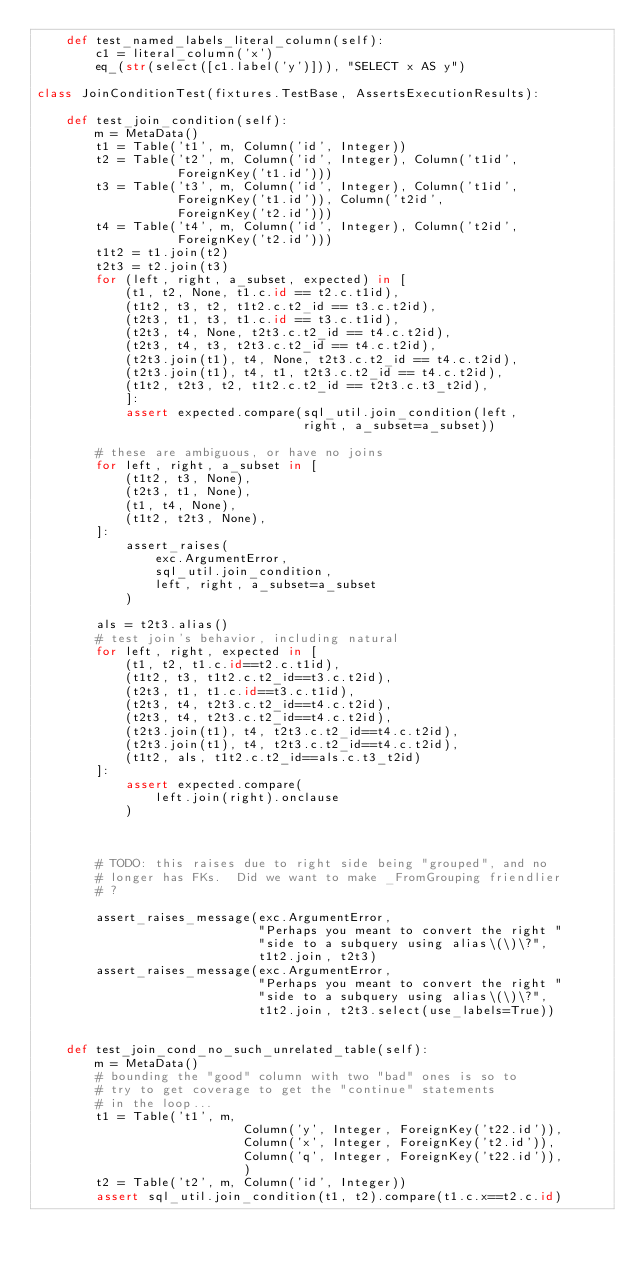Convert code to text. <code><loc_0><loc_0><loc_500><loc_500><_Python_>    def test_named_labels_literal_column(self):
        c1 = literal_column('x')
        eq_(str(select([c1.label('y')])), "SELECT x AS y")

class JoinConditionTest(fixtures.TestBase, AssertsExecutionResults):

    def test_join_condition(self):
        m = MetaData()
        t1 = Table('t1', m, Column('id', Integer))
        t2 = Table('t2', m, Column('id', Integer), Column('t1id',
                   ForeignKey('t1.id')))
        t3 = Table('t3', m, Column('id', Integer), Column('t1id',
                   ForeignKey('t1.id')), Column('t2id',
                   ForeignKey('t2.id')))
        t4 = Table('t4', m, Column('id', Integer), Column('t2id',
                   ForeignKey('t2.id')))
        t1t2 = t1.join(t2)
        t2t3 = t2.join(t3)
        for (left, right, a_subset, expected) in [
            (t1, t2, None, t1.c.id == t2.c.t1id),
            (t1t2, t3, t2, t1t2.c.t2_id == t3.c.t2id),
            (t2t3, t1, t3, t1.c.id == t3.c.t1id),
            (t2t3, t4, None, t2t3.c.t2_id == t4.c.t2id),
            (t2t3, t4, t3, t2t3.c.t2_id == t4.c.t2id),
            (t2t3.join(t1), t4, None, t2t3.c.t2_id == t4.c.t2id),
            (t2t3.join(t1), t4, t1, t2t3.c.t2_id == t4.c.t2id),
            (t1t2, t2t3, t2, t1t2.c.t2_id == t2t3.c.t3_t2id),
            ]:
            assert expected.compare(sql_util.join_condition(left,
                                    right, a_subset=a_subset))

        # these are ambiguous, or have no joins
        for left, right, a_subset in [
            (t1t2, t3, None),
            (t2t3, t1, None),
            (t1, t4, None),
            (t1t2, t2t3, None),
        ]:
            assert_raises(
                exc.ArgumentError,
                sql_util.join_condition,
                left, right, a_subset=a_subset
            )

        als = t2t3.alias()
        # test join's behavior, including natural
        for left, right, expected in [
            (t1, t2, t1.c.id==t2.c.t1id),
            (t1t2, t3, t1t2.c.t2_id==t3.c.t2id),
            (t2t3, t1, t1.c.id==t3.c.t1id),
            (t2t3, t4, t2t3.c.t2_id==t4.c.t2id),
            (t2t3, t4, t2t3.c.t2_id==t4.c.t2id),
            (t2t3.join(t1), t4, t2t3.c.t2_id==t4.c.t2id),
            (t2t3.join(t1), t4, t2t3.c.t2_id==t4.c.t2id),
            (t1t2, als, t1t2.c.t2_id==als.c.t3_t2id)
        ]:
            assert expected.compare(
                left.join(right).onclause
            )



        # TODO: this raises due to right side being "grouped", and no
        # longer has FKs.  Did we want to make _FromGrouping friendlier
        # ?

        assert_raises_message(exc.ArgumentError,
                              "Perhaps you meant to convert the right "
                              "side to a subquery using alias\(\)\?",
                              t1t2.join, t2t3)
        assert_raises_message(exc.ArgumentError,
                              "Perhaps you meant to convert the right "
                              "side to a subquery using alias\(\)\?",
                              t1t2.join, t2t3.select(use_labels=True))


    def test_join_cond_no_such_unrelated_table(self):
        m = MetaData()
        # bounding the "good" column with two "bad" ones is so to 
        # try to get coverage to get the "continue" statements
        # in the loop...
        t1 = Table('t1', m, 
                            Column('y', Integer, ForeignKey('t22.id')),
                            Column('x', Integer, ForeignKey('t2.id')), 
                            Column('q', Integer, ForeignKey('t22.id')), 
                            )
        t2 = Table('t2', m, Column('id', Integer))
        assert sql_util.join_condition(t1, t2).compare(t1.c.x==t2.c.id)</code> 